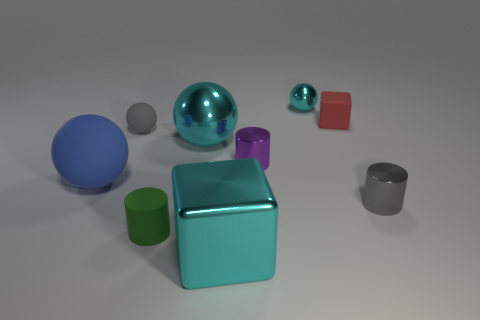Subtract all tiny metallic cylinders. How many cylinders are left? 1 Subtract all gray balls. How many balls are left? 3 Subtract 1 balls. How many balls are left? 3 Subtract all yellow balls. Subtract all purple cubes. How many balls are left? 4 Add 1 small gray rubber objects. How many objects exist? 10 Subtract all blocks. How many objects are left? 7 Subtract all big brown matte cylinders. Subtract all red blocks. How many objects are left? 8 Add 6 big shiny objects. How many big shiny objects are left? 8 Add 9 tiny blue shiny things. How many tiny blue shiny things exist? 9 Subtract 0 yellow cylinders. How many objects are left? 9 